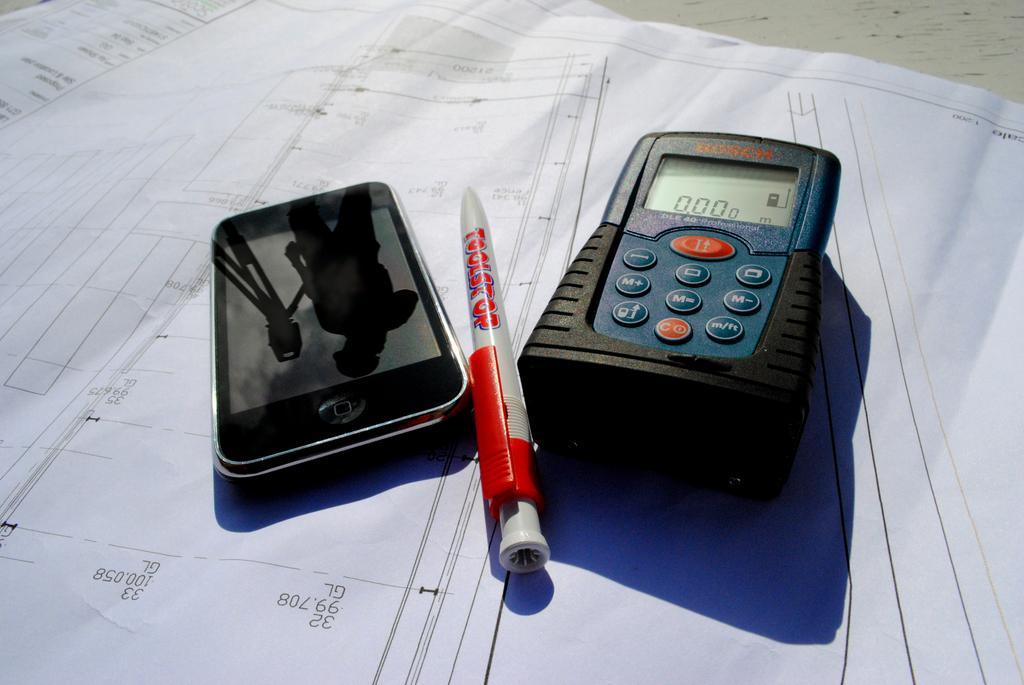Please provide a concise description of this image. In this image we can see a mobile, pen and a multimeter. In the background of the image there are papers and a white surface. 